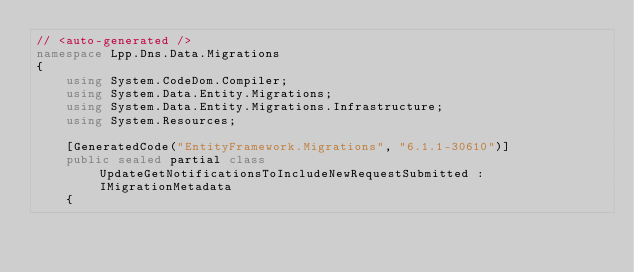Convert code to text. <code><loc_0><loc_0><loc_500><loc_500><_C#_>// <auto-generated />
namespace Lpp.Dns.Data.Migrations
{
    using System.CodeDom.Compiler;
    using System.Data.Entity.Migrations;
    using System.Data.Entity.Migrations.Infrastructure;
    using System.Resources;
    
    [GeneratedCode("EntityFramework.Migrations", "6.1.1-30610")]
    public sealed partial class UpdateGetNotificationsToIncludeNewRequestSubmitted : IMigrationMetadata
    {</code> 